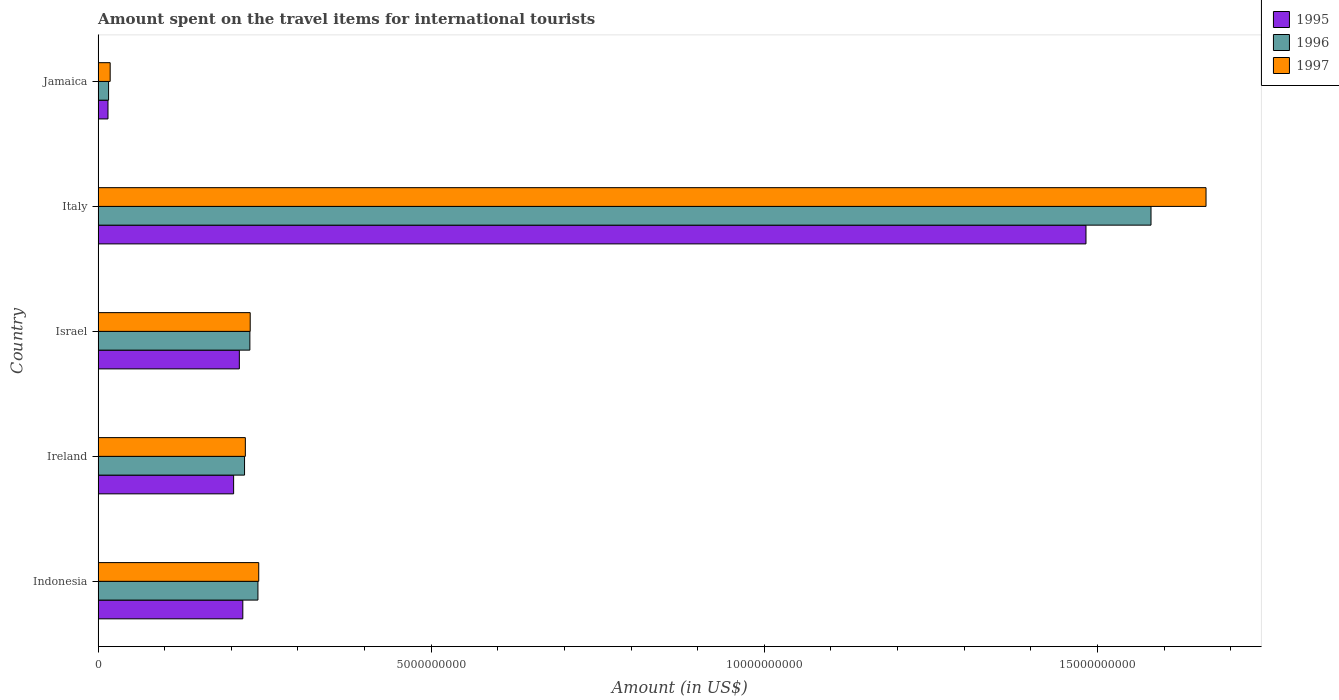How many different coloured bars are there?
Make the answer very short. 3. How many groups of bars are there?
Offer a terse response. 5. Are the number of bars per tick equal to the number of legend labels?
Offer a very short reply. Yes. How many bars are there on the 3rd tick from the top?
Ensure brevity in your answer.  3. In how many cases, is the number of bars for a given country not equal to the number of legend labels?
Offer a very short reply. 0. What is the amount spent on the travel items for international tourists in 1997 in Italy?
Keep it short and to the point. 1.66e+1. Across all countries, what is the maximum amount spent on the travel items for international tourists in 1995?
Your answer should be compact. 1.48e+1. Across all countries, what is the minimum amount spent on the travel items for international tourists in 1996?
Keep it short and to the point. 1.57e+08. In which country was the amount spent on the travel items for international tourists in 1995 minimum?
Give a very brief answer. Jamaica. What is the total amount spent on the travel items for international tourists in 1997 in the graph?
Your answer should be compact. 2.37e+1. What is the difference between the amount spent on the travel items for international tourists in 1996 in Indonesia and that in Jamaica?
Offer a terse response. 2.24e+09. What is the difference between the amount spent on the travel items for international tourists in 1997 in Italy and the amount spent on the travel items for international tourists in 1996 in Ireland?
Provide a short and direct response. 1.44e+1. What is the average amount spent on the travel items for international tourists in 1996 per country?
Ensure brevity in your answer.  4.57e+09. What is the difference between the amount spent on the travel items for international tourists in 1997 and amount spent on the travel items for international tourists in 1996 in Indonesia?
Ensure brevity in your answer.  1.20e+07. In how many countries, is the amount spent on the travel items for international tourists in 1996 greater than 9000000000 US$?
Provide a succinct answer. 1. What is the ratio of the amount spent on the travel items for international tourists in 1997 in Indonesia to that in Israel?
Ensure brevity in your answer.  1.06. Is the amount spent on the travel items for international tourists in 1997 in Ireland less than that in Italy?
Ensure brevity in your answer.  Yes. What is the difference between the highest and the second highest amount spent on the travel items for international tourists in 1997?
Your answer should be compact. 1.42e+1. What is the difference between the highest and the lowest amount spent on the travel items for international tourists in 1997?
Your answer should be very brief. 1.64e+1. In how many countries, is the amount spent on the travel items for international tourists in 1996 greater than the average amount spent on the travel items for international tourists in 1996 taken over all countries?
Provide a short and direct response. 1. Is the sum of the amount spent on the travel items for international tourists in 1995 in Indonesia and Israel greater than the maximum amount spent on the travel items for international tourists in 1997 across all countries?
Offer a very short reply. No. What does the 2nd bar from the bottom in Indonesia represents?
Offer a terse response. 1996. Is it the case that in every country, the sum of the amount spent on the travel items for international tourists in 1996 and amount spent on the travel items for international tourists in 1995 is greater than the amount spent on the travel items for international tourists in 1997?
Give a very brief answer. Yes. How many countries are there in the graph?
Provide a succinct answer. 5. Are the values on the major ticks of X-axis written in scientific E-notation?
Your response must be concise. No. Does the graph contain grids?
Offer a very short reply. No. Where does the legend appear in the graph?
Give a very brief answer. Top right. How are the legend labels stacked?
Your answer should be very brief. Vertical. What is the title of the graph?
Your answer should be very brief. Amount spent on the travel items for international tourists. What is the label or title of the Y-axis?
Your answer should be compact. Country. What is the Amount (in US$) in 1995 in Indonesia?
Offer a very short reply. 2.17e+09. What is the Amount (in US$) of 1996 in Indonesia?
Provide a short and direct response. 2.40e+09. What is the Amount (in US$) in 1997 in Indonesia?
Offer a very short reply. 2.41e+09. What is the Amount (in US$) of 1995 in Ireland?
Keep it short and to the point. 2.03e+09. What is the Amount (in US$) in 1996 in Ireland?
Offer a terse response. 2.20e+09. What is the Amount (in US$) of 1997 in Ireland?
Offer a very short reply. 2.21e+09. What is the Amount (in US$) of 1995 in Israel?
Provide a succinct answer. 2.12e+09. What is the Amount (in US$) of 1996 in Israel?
Keep it short and to the point. 2.28e+09. What is the Amount (in US$) of 1997 in Israel?
Keep it short and to the point. 2.28e+09. What is the Amount (in US$) in 1995 in Italy?
Ensure brevity in your answer.  1.48e+1. What is the Amount (in US$) in 1996 in Italy?
Provide a succinct answer. 1.58e+1. What is the Amount (in US$) in 1997 in Italy?
Provide a short and direct response. 1.66e+1. What is the Amount (in US$) in 1995 in Jamaica?
Give a very brief answer. 1.48e+08. What is the Amount (in US$) of 1996 in Jamaica?
Make the answer very short. 1.57e+08. What is the Amount (in US$) in 1997 in Jamaica?
Keep it short and to the point. 1.81e+08. Across all countries, what is the maximum Amount (in US$) in 1995?
Your answer should be compact. 1.48e+1. Across all countries, what is the maximum Amount (in US$) in 1996?
Make the answer very short. 1.58e+1. Across all countries, what is the maximum Amount (in US$) of 1997?
Provide a succinct answer. 1.66e+1. Across all countries, what is the minimum Amount (in US$) in 1995?
Give a very brief answer. 1.48e+08. Across all countries, what is the minimum Amount (in US$) of 1996?
Ensure brevity in your answer.  1.57e+08. Across all countries, what is the minimum Amount (in US$) in 1997?
Keep it short and to the point. 1.81e+08. What is the total Amount (in US$) of 1995 in the graph?
Offer a very short reply. 2.13e+1. What is the total Amount (in US$) of 1996 in the graph?
Offer a very short reply. 2.28e+1. What is the total Amount (in US$) of 1997 in the graph?
Your answer should be compact. 2.37e+1. What is the difference between the Amount (in US$) in 1995 in Indonesia and that in Ireland?
Keep it short and to the point. 1.38e+08. What is the difference between the Amount (in US$) in 1996 in Indonesia and that in Ireland?
Give a very brief answer. 2.01e+08. What is the difference between the Amount (in US$) in 1997 in Indonesia and that in Ireland?
Provide a short and direct response. 2.01e+08. What is the difference between the Amount (in US$) in 1995 in Indonesia and that in Israel?
Provide a short and direct response. 5.20e+07. What is the difference between the Amount (in US$) of 1996 in Indonesia and that in Israel?
Your answer should be very brief. 1.21e+08. What is the difference between the Amount (in US$) in 1997 in Indonesia and that in Israel?
Your response must be concise. 1.28e+08. What is the difference between the Amount (in US$) in 1995 in Indonesia and that in Italy?
Give a very brief answer. -1.27e+1. What is the difference between the Amount (in US$) in 1996 in Indonesia and that in Italy?
Offer a very short reply. -1.34e+1. What is the difference between the Amount (in US$) of 1997 in Indonesia and that in Italy?
Offer a very short reply. -1.42e+1. What is the difference between the Amount (in US$) in 1995 in Indonesia and that in Jamaica?
Make the answer very short. 2.02e+09. What is the difference between the Amount (in US$) of 1996 in Indonesia and that in Jamaica?
Give a very brief answer. 2.24e+09. What is the difference between the Amount (in US$) of 1997 in Indonesia and that in Jamaica?
Keep it short and to the point. 2.23e+09. What is the difference between the Amount (in US$) of 1995 in Ireland and that in Israel?
Provide a succinct answer. -8.60e+07. What is the difference between the Amount (in US$) in 1996 in Ireland and that in Israel?
Offer a terse response. -8.00e+07. What is the difference between the Amount (in US$) in 1997 in Ireland and that in Israel?
Provide a succinct answer. -7.30e+07. What is the difference between the Amount (in US$) of 1995 in Ireland and that in Italy?
Give a very brief answer. -1.28e+1. What is the difference between the Amount (in US$) of 1996 in Ireland and that in Italy?
Provide a short and direct response. -1.36e+1. What is the difference between the Amount (in US$) in 1997 in Ireland and that in Italy?
Offer a terse response. -1.44e+1. What is the difference between the Amount (in US$) in 1995 in Ireland and that in Jamaica?
Give a very brief answer. 1.89e+09. What is the difference between the Amount (in US$) in 1996 in Ireland and that in Jamaica?
Your answer should be very brief. 2.04e+09. What is the difference between the Amount (in US$) in 1997 in Ireland and that in Jamaica?
Make the answer very short. 2.03e+09. What is the difference between the Amount (in US$) in 1995 in Israel and that in Italy?
Your answer should be compact. -1.27e+1. What is the difference between the Amount (in US$) of 1996 in Israel and that in Italy?
Provide a short and direct response. -1.35e+1. What is the difference between the Amount (in US$) in 1997 in Israel and that in Italy?
Make the answer very short. -1.43e+1. What is the difference between the Amount (in US$) in 1995 in Israel and that in Jamaica?
Make the answer very short. 1.97e+09. What is the difference between the Amount (in US$) of 1996 in Israel and that in Jamaica?
Offer a very short reply. 2.12e+09. What is the difference between the Amount (in US$) of 1997 in Israel and that in Jamaica?
Your answer should be very brief. 2.10e+09. What is the difference between the Amount (in US$) of 1995 in Italy and that in Jamaica?
Give a very brief answer. 1.47e+1. What is the difference between the Amount (in US$) of 1996 in Italy and that in Jamaica?
Your response must be concise. 1.56e+1. What is the difference between the Amount (in US$) in 1997 in Italy and that in Jamaica?
Give a very brief answer. 1.64e+1. What is the difference between the Amount (in US$) in 1995 in Indonesia and the Amount (in US$) in 1996 in Ireland?
Give a very brief answer. -2.60e+07. What is the difference between the Amount (in US$) in 1995 in Indonesia and the Amount (in US$) in 1997 in Ireland?
Your response must be concise. -3.80e+07. What is the difference between the Amount (in US$) in 1996 in Indonesia and the Amount (in US$) in 1997 in Ireland?
Provide a short and direct response. 1.89e+08. What is the difference between the Amount (in US$) in 1995 in Indonesia and the Amount (in US$) in 1996 in Israel?
Provide a succinct answer. -1.06e+08. What is the difference between the Amount (in US$) of 1995 in Indonesia and the Amount (in US$) of 1997 in Israel?
Make the answer very short. -1.11e+08. What is the difference between the Amount (in US$) of 1996 in Indonesia and the Amount (in US$) of 1997 in Israel?
Your answer should be compact. 1.16e+08. What is the difference between the Amount (in US$) of 1995 in Indonesia and the Amount (in US$) of 1996 in Italy?
Your response must be concise. -1.36e+1. What is the difference between the Amount (in US$) of 1995 in Indonesia and the Amount (in US$) of 1997 in Italy?
Your response must be concise. -1.45e+1. What is the difference between the Amount (in US$) in 1996 in Indonesia and the Amount (in US$) in 1997 in Italy?
Ensure brevity in your answer.  -1.42e+1. What is the difference between the Amount (in US$) in 1995 in Indonesia and the Amount (in US$) in 1996 in Jamaica?
Provide a short and direct response. 2.02e+09. What is the difference between the Amount (in US$) of 1995 in Indonesia and the Amount (in US$) of 1997 in Jamaica?
Ensure brevity in your answer.  1.99e+09. What is the difference between the Amount (in US$) of 1996 in Indonesia and the Amount (in US$) of 1997 in Jamaica?
Your answer should be very brief. 2.22e+09. What is the difference between the Amount (in US$) of 1995 in Ireland and the Amount (in US$) of 1996 in Israel?
Ensure brevity in your answer.  -2.44e+08. What is the difference between the Amount (in US$) in 1995 in Ireland and the Amount (in US$) in 1997 in Israel?
Your response must be concise. -2.49e+08. What is the difference between the Amount (in US$) in 1996 in Ireland and the Amount (in US$) in 1997 in Israel?
Give a very brief answer. -8.50e+07. What is the difference between the Amount (in US$) in 1995 in Ireland and the Amount (in US$) in 1996 in Italy?
Ensure brevity in your answer.  -1.38e+1. What is the difference between the Amount (in US$) of 1995 in Ireland and the Amount (in US$) of 1997 in Italy?
Offer a very short reply. -1.46e+1. What is the difference between the Amount (in US$) of 1996 in Ireland and the Amount (in US$) of 1997 in Italy?
Your response must be concise. -1.44e+1. What is the difference between the Amount (in US$) in 1995 in Ireland and the Amount (in US$) in 1996 in Jamaica?
Provide a short and direct response. 1.88e+09. What is the difference between the Amount (in US$) in 1995 in Ireland and the Amount (in US$) in 1997 in Jamaica?
Provide a short and direct response. 1.85e+09. What is the difference between the Amount (in US$) of 1996 in Ireland and the Amount (in US$) of 1997 in Jamaica?
Provide a short and direct response. 2.02e+09. What is the difference between the Amount (in US$) of 1995 in Israel and the Amount (in US$) of 1996 in Italy?
Provide a succinct answer. -1.37e+1. What is the difference between the Amount (in US$) of 1995 in Israel and the Amount (in US$) of 1997 in Italy?
Your response must be concise. -1.45e+1. What is the difference between the Amount (in US$) in 1996 in Israel and the Amount (in US$) in 1997 in Italy?
Keep it short and to the point. -1.44e+1. What is the difference between the Amount (in US$) in 1995 in Israel and the Amount (in US$) in 1996 in Jamaica?
Offer a terse response. 1.96e+09. What is the difference between the Amount (in US$) in 1995 in Israel and the Amount (in US$) in 1997 in Jamaica?
Your answer should be compact. 1.94e+09. What is the difference between the Amount (in US$) in 1996 in Israel and the Amount (in US$) in 1997 in Jamaica?
Your response must be concise. 2.10e+09. What is the difference between the Amount (in US$) of 1995 in Italy and the Amount (in US$) of 1996 in Jamaica?
Offer a very short reply. 1.47e+1. What is the difference between the Amount (in US$) of 1995 in Italy and the Amount (in US$) of 1997 in Jamaica?
Make the answer very short. 1.46e+1. What is the difference between the Amount (in US$) in 1996 in Italy and the Amount (in US$) in 1997 in Jamaica?
Provide a succinct answer. 1.56e+1. What is the average Amount (in US$) of 1995 per country?
Ensure brevity in your answer.  4.26e+09. What is the average Amount (in US$) in 1996 per country?
Your response must be concise. 4.57e+09. What is the average Amount (in US$) of 1997 per country?
Your answer should be very brief. 4.74e+09. What is the difference between the Amount (in US$) in 1995 and Amount (in US$) in 1996 in Indonesia?
Make the answer very short. -2.27e+08. What is the difference between the Amount (in US$) of 1995 and Amount (in US$) of 1997 in Indonesia?
Offer a very short reply. -2.39e+08. What is the difference between the Amount (in US$) in 1996 and Amount (in US$) in 1997 in Indonesia?
Keep it short and to the point. -1.20e+07. What is the difference between the Amount (in US$) in 1995 and Amount (in US$) in 1996 in Ireland?
Keep it short and to the point. -1.64e+08. What is the difference between the Amount (in US$) in 1995 and Amount (in US$) in 1997 in Ireland?
Offer a terse response. -1.76e+08. What is the difference between the Amount (in US$) of 1996 and Amount (in US$) of 1997 in Ireland?
Keep it short and to the point. -1.20e+07. What is the difference between the Amount (in US$) in 1995 and Amount (in US$) in 1996 in Israel?
Offer a terse response. -1.58e+08. What is the difference between the Amount (in US$) of 1995 and Amount (in US$) of 1997 in Israel?
Your answer should be compact. -1.63e+08. What is the difference between the Amount (in US$) in 1996 and Amount (in US$) in 1997 in Israel?
Offer a very short reply. -5.00e+06. What is the difference between the Amount (in US$) of 1995 and Amount (in US$) of 1996 in Italy?
Make the answer very short. -9.76e+08. What is the difference between the Amount (in US$) in 1995 and Amount (in US$) in 1997 in Italy?
Your answer should be compact. -1.80e+09. What is the difference between the Amount (in US$) of 1996 and Amount (in US$) of 1997 in Italy?
Provide a succinct answer. -8.26e+08. What is the difference between the Amount (in US$) of 1995 and Amount (in US$) of 1996 in Jamaica?
Your answer should be very brief. -9.00e+06. What is the difference between the Amount (in US$) in 1995 and Amount (in US$) in 1997 in Jamaica?
Provide a short and direct response. -3.30e+07. What is the difference between the Amount (in US$) in 1996 and Amount (in US$) in 1997 in Jamaica?
Give a very brief answer. -2.40e+07. What is the ratio of the Amount (in US$) of 1995 in Indonesia to that in Ireland?
Ensure brevity in your answer.  1.07. What is the ratio of the Amount (in US$) in 1996 in Indonesia to that in Ireland?
Give a very brief answer. 1.09. What is the ratio of the Amount (in US$) of 1997 in Indonesia to that in Ireland?
Your response must be concise. 1.09. What is the ratio of the Amount (in US$) in 1995 in Indonesia to that in Israel?
Your answer should be compact. 1.02. What is the ratio of the Amount (in US$) of 1996 in Indonesia to that in Israel?
Give a very brief answer. 1.05. What is the ratio of the Amount (in US$) of 1997 in Indonesia to that in Israel?
Give a very brief answer. 1.06. What is the ratio of the Amount (in US$) in 1995 in Indonesia to that in Italy?
Keep it short and to the point. 0.15. What is the ratio of the Amount (in US$) of 1996 in Indonesia to that in Italy?
Provide a succinct answer. 0.15. What is the ratio of the Amount (in US$) of 1997 in Indonesia to that in Italy?
Make the answer very short. 0.14. What is the ratio of the Amount (in US$) of 1995 in Indonesia to that in Jamaica?
Ensure brevity in your answer.  14.68. What is the ratio of the Amount (in US$) of 1996 in Indonesia to that in Jamaica?
Your answer should be compact. 15.28. What is the ratio of the Amount (in US$) of 1997 in Indonesia to that in Jamaica?
Your answer should be very brief. 13.32. What is the ratio of the Amount (in US$) in 1995 in Ireland to that in Israel?
Provide a short and direct response. 0.96. What is the ratio of the Amount (in US$) of 1996 in Ireland to that in Israel?
Provide a succinct answer. 0.96. What is the ratio of the Amount (in US$) of 1995 in Ireland to that in Italy?
Your response must be concise. 0.14. What is the ratio of the Amount (in US$) in 1996 in Ireland to that in Italy?
Keep it short and to the point. 0.14. What is the ratio of the Amount (in US$) of 1997 in Ireland to that in Italy?
Make the answer very short. 0.13. What is the ratio of the Amount (in US$) in 1995 in Ireland to that in Jamaica?
Provide a succinct answer. 13.74. What is the ratio of the Amount (in US$) in 1997 in Ireland to that in Jamaica?
Ensure brevity in your answer.  12.21. What is the ratio of the Amount (in US$) in 1995 in Israel to that in Italy?
Offer a terse response. 0.14. What is the ratio of the Amount (in US$) of 1996 in Israel to that in Italy?
Make the answer very short. 0.14. What is the ratio of the Amount (in US$) of 1997 in Israel to that in Italy?
Ensure brevity in your answer.  0.14. What is the ratio of the Amount (in US$) of 1995 in Israel to that in Jamaica?
Provide a short and direct response. 14.32. What is the ratio of the Amount (in US$) of 1996 in Israel to that in Jamaica?
Offer a terse response. 14.51. What is the ratio of the Amount (in US$) in 1997 in Israel to that in Jamaica?
Offer a terse response. 12.61. What is the ratio of the Amount (in US$) of 1995 in Italy to that in Jamaica?
Offer a very short reply. 100.2. What is the ratio of the Amount (in US$) of 1996 in Italy to that in Jamaica?
Make the answer very short. 100.67. What is the ratio of the Amount (in US$) in 1997 in Italy to that in Jamaica?
Offer a terse response. 91.88. What is the difference between the highest and the second highest Amount (in US$) of 1995?
Provide a succinct answer. 1.27e+1. What is the difference between the highest and the second highest Amount (in US$) of 1996?
Your response must be concise. 1.34e+1. What is the difference between the highest and the second highest Amount (in US$) in 1997?
Provide a short and direct response. 1.42e+1. What is the difference between the highest and the lowest Amount (in US$) in 1995?
Your response must be concise. 1.47e+1. What is the difference between the highest and the lowest Amount (in US$) in 1996?
Your response must be concise. 1.56e+1. What is the difference between the highest and the lowest Amount (in US$) in 1997?
Your answer should be very brief. 1.64e+1. 